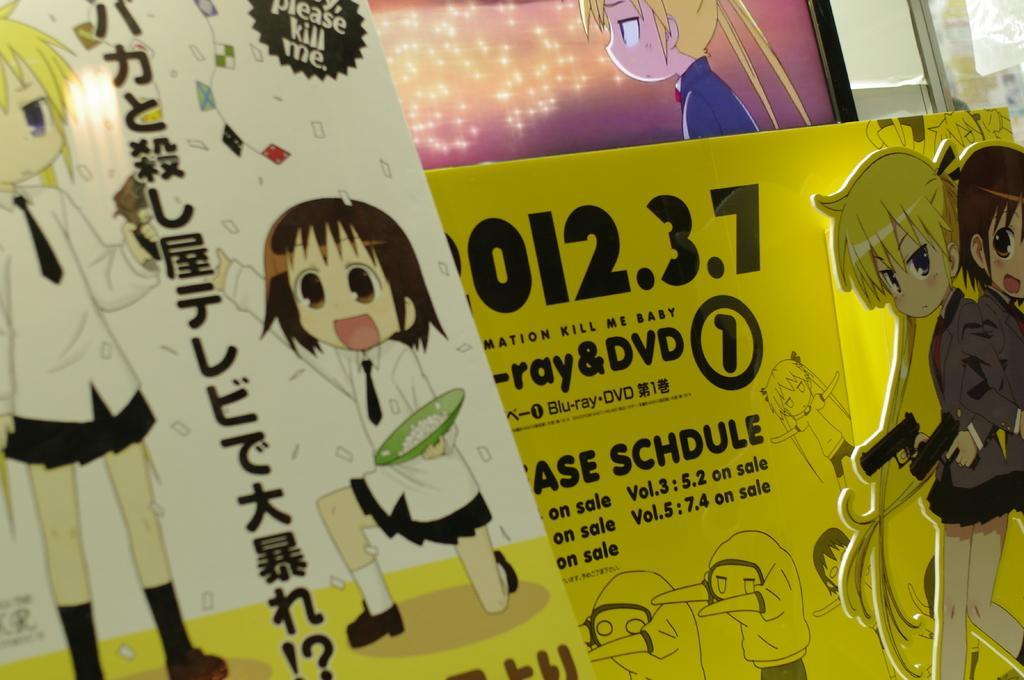How would you summarize this image in a sentence or two? In the foreground of this image, there are two boards and it seems like screen on the top. 